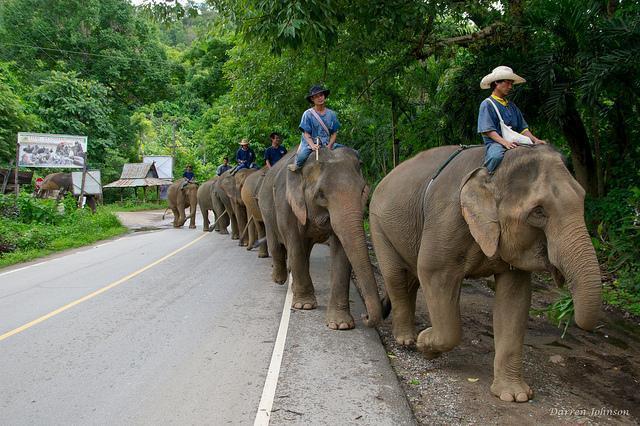What is on top of the elephants?
Choose the correct response, then elucidate: 'Answer: answer
Rationale: rationale.'
Options: Bows, ladders, statues, people. Answer: people.
Rationale: Many humans are sitting atop an elephant. they are marching across a road to get to the woods. 